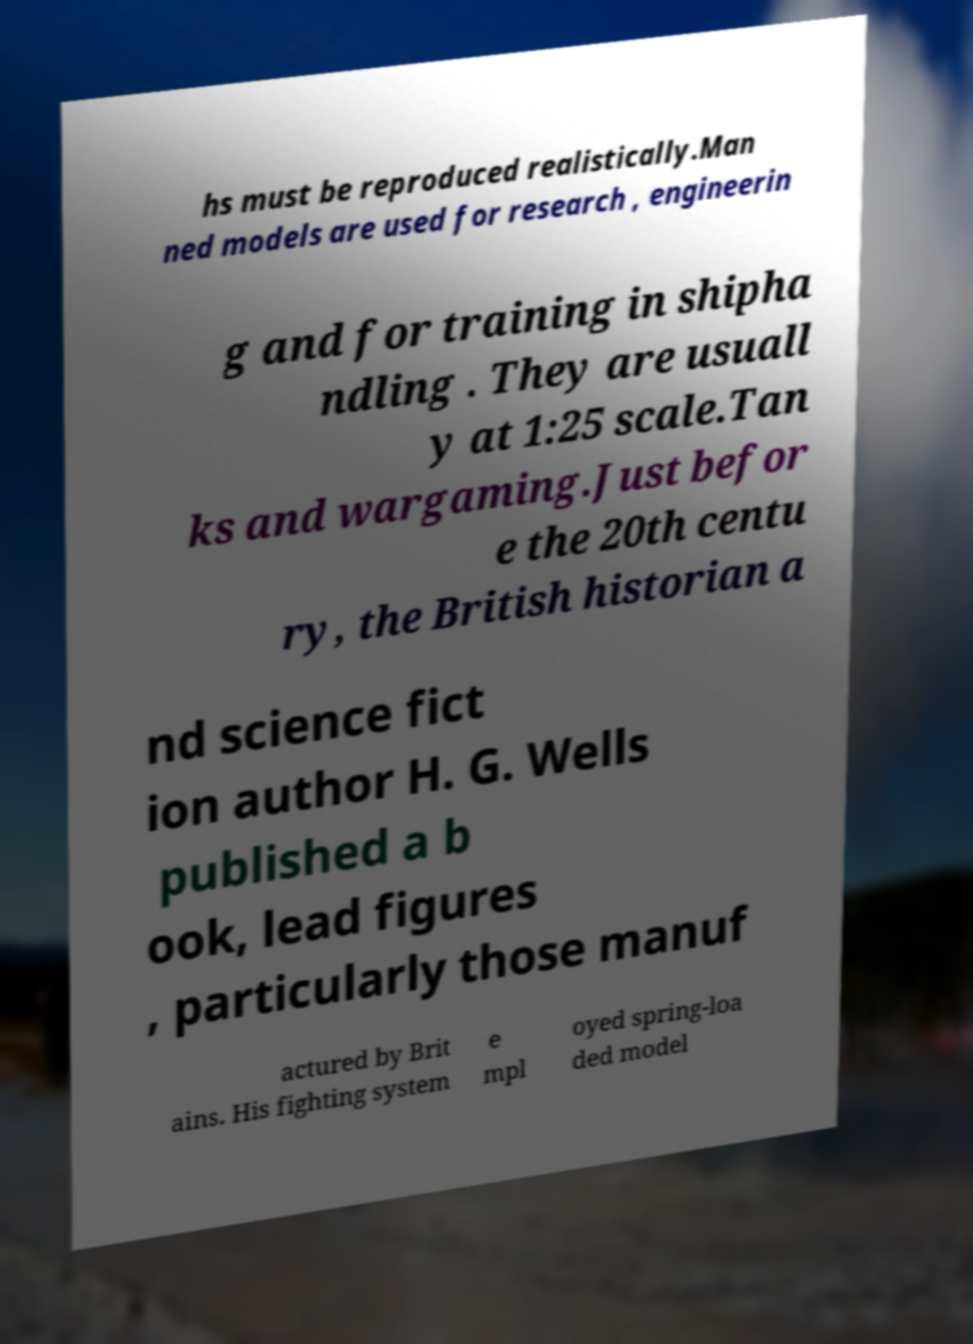What messages or text are displayed in this image? I need them in a readable, typed format. hs must be reproduced realistically.Man ned models are used for research , engineerin g and for training in shipha ndling . They are usuall y at 1:25 scale.Tan ks and wargaming.Just befor e the 20th centu ry, the British historian a nd science fict ion author H. G. Wells published a b ook, lead figures , particularly those manuf actured by Brit ains. His fighting system e mpl oyed spring-loa ded model 